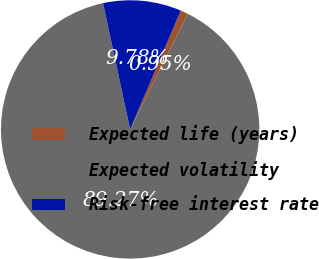<chart> <loc_0><loc_0><loc_500><loc_500><pie_chart><fcel>Expected life (years)<fcel>Expected volatility<fcel>Risk-free interest rate<nl><fcel>0.95%<fcel>89.26%<fcel>9.78%<nl></chart> 